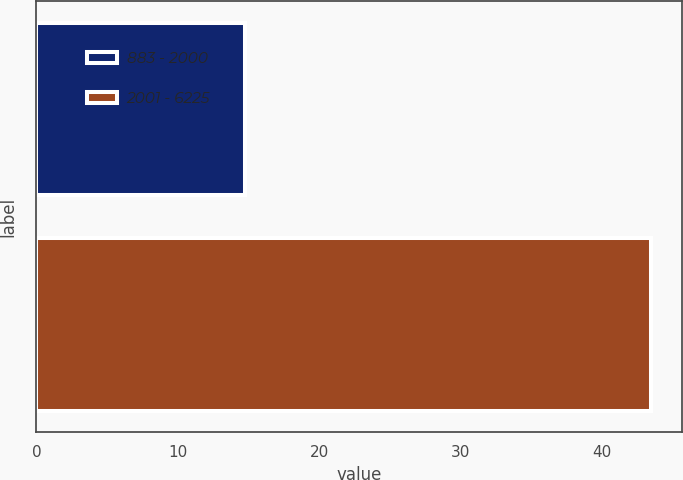Convert chart. <chart><loc_0><loc_0><loc_500><loc_500><bar_chart><fcel>883 - 2000<fcel>2001 - 6225<nl><fcel>14.75<fcel>43.53<nl></chart> 